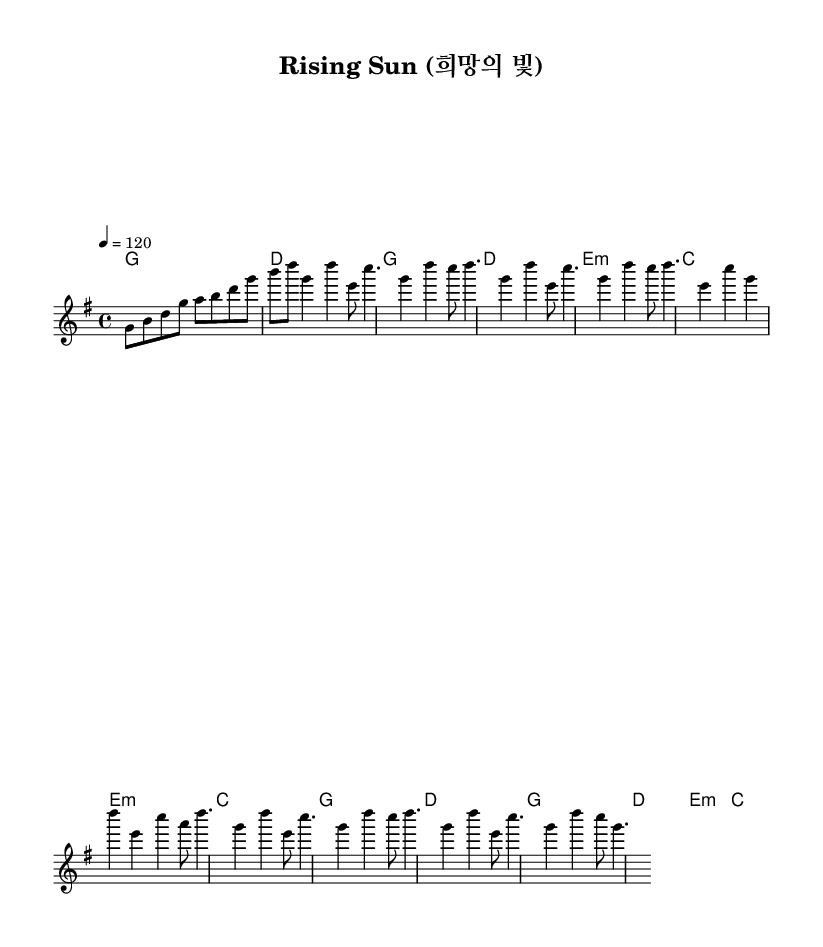What is the key signature of this music? The music is in G major, indicated by the sharp sign on the F line in the key signature at the beginning of the score.
Answer: G major What is the time signature of this piece? The time signature is 4/4, which is shown at the beginning of the score, indicating that there are four beats per measure.
Answer: 4/4 What is the tempo marking for this piece? The tempo marking is 120 beats per minute, which is located at the start of the score, indicating how fast the piece should be played.
Answer: 120 How many measures are in the chorus section? The chorus consists of four measures, as indicated by counting the measures in the melody section labeled as the Chorus.
Answer: 4 What type of harmony is used in the pre-chorus section? The pre-chorus features minor harmony, specifically indicated by the presence of e minor chord, which can be seen through the harmony section in the chord names.
Answer: Minor Is this music primarily vocal or instrumental in nature? This music is primarily vocal, as it follows the structure and common themes of K-Pop, focusing on uplifting lyrics that celebrate resilience and hope.
Answer: Vocal 